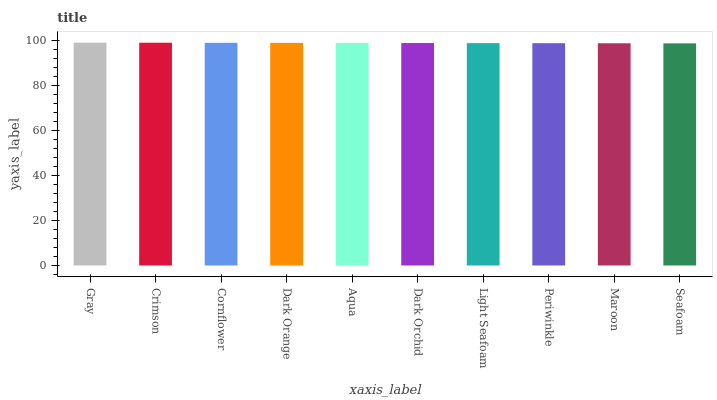Is Seafoam the minimum?
Answer yes or no. Yes. Is Gray the maximum?
Answer yes or no. Yes. Is Crimson the minimum?
Answer yes or no. No. Is Crimson the maximum?
Answer yes or no. No. Is Gray greater than Crimson?
Answer yes or no. Yes. Is Crimson less than Gray?
Answer yes or no. Yes. Is Crimson greater than Gray?
Answer yes or no. No. Is Gray less than Crimson?
Answer yes or no. No. Is Aqua the high median?
Answer yes or no. Yes. Is Dark Orchid the low median?
Answer yes or no. Yes. Is Cornflower the high median?
Answer yes or no. No. Is Cornflower the low median?
Answer yes or no. No. 